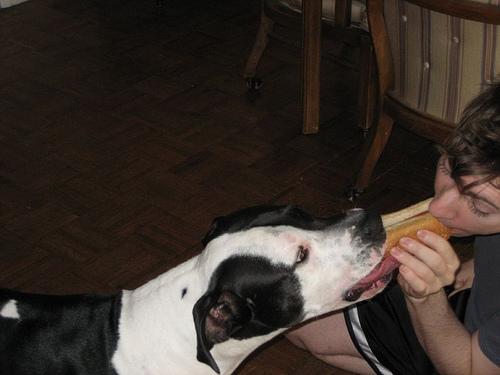What color is the dog's nose?
Be succinct. Black. Is there a cat in the picture?
Short answer required. No. What is the person sharing with the dog?
Short answer required. Hot dog. 